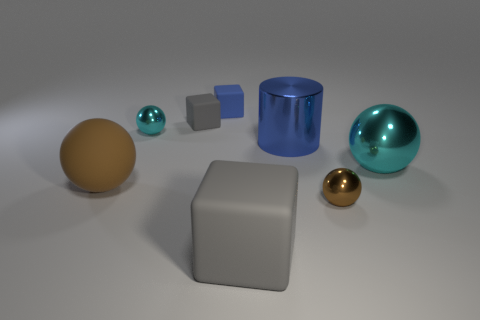Subtract all gray rubber cubes. How many cubes are left? 1 Add 1 blue rubber objects. How many objects exist? 9 Subtract all green cylinders. How many cyan spheres are left? 2 Subtract all cyan balls. How many balls are left? 2 Subtract all cylinders. How many objects are left? 7 Add 7 small spheres. How many small spheres exist? 9 Subtract 0 yellow spheres. How many objects are left? 8 Subtract all green cylinders. Subtract all yellow balls. How many cylinders are left? 1 Subtract all rubber blocks. Subtract all small cyan objects. How many objects are left? 4 Add 8 large brown rubber spheres. How many large brown rubber spheres are left? 9 